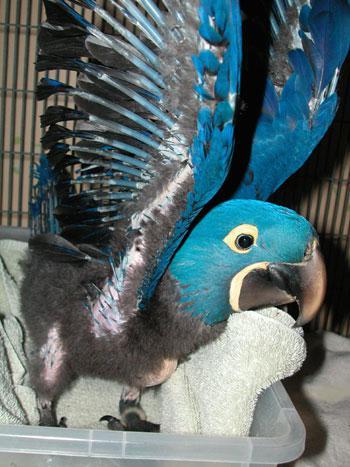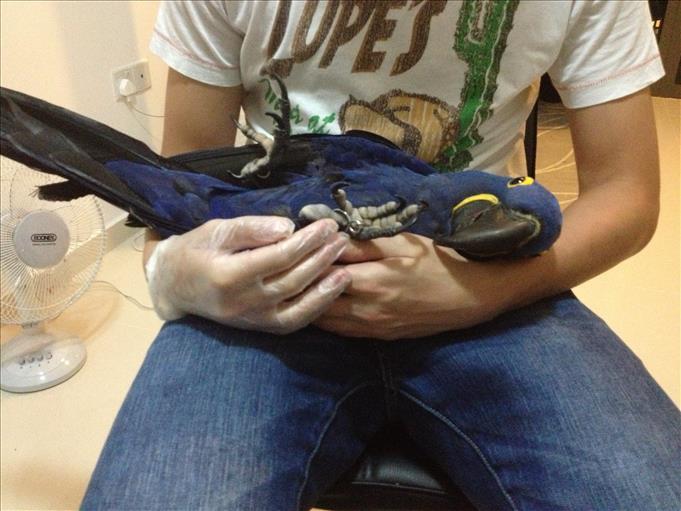The first image is the image on the left, the second image is the image on the right. Evaluate the accuracy of this statement regarding the images: "The right image contains at least two blue parrots.". Is it true? Answer yes or no. No. The first image is the image on the left, the second image is the image on the right. Given the left and right images, does the statement "Each image contains at least two blue-feathered birds, and one image shows birds perched on leafless branches." hold true? Answer yes or no. No. 